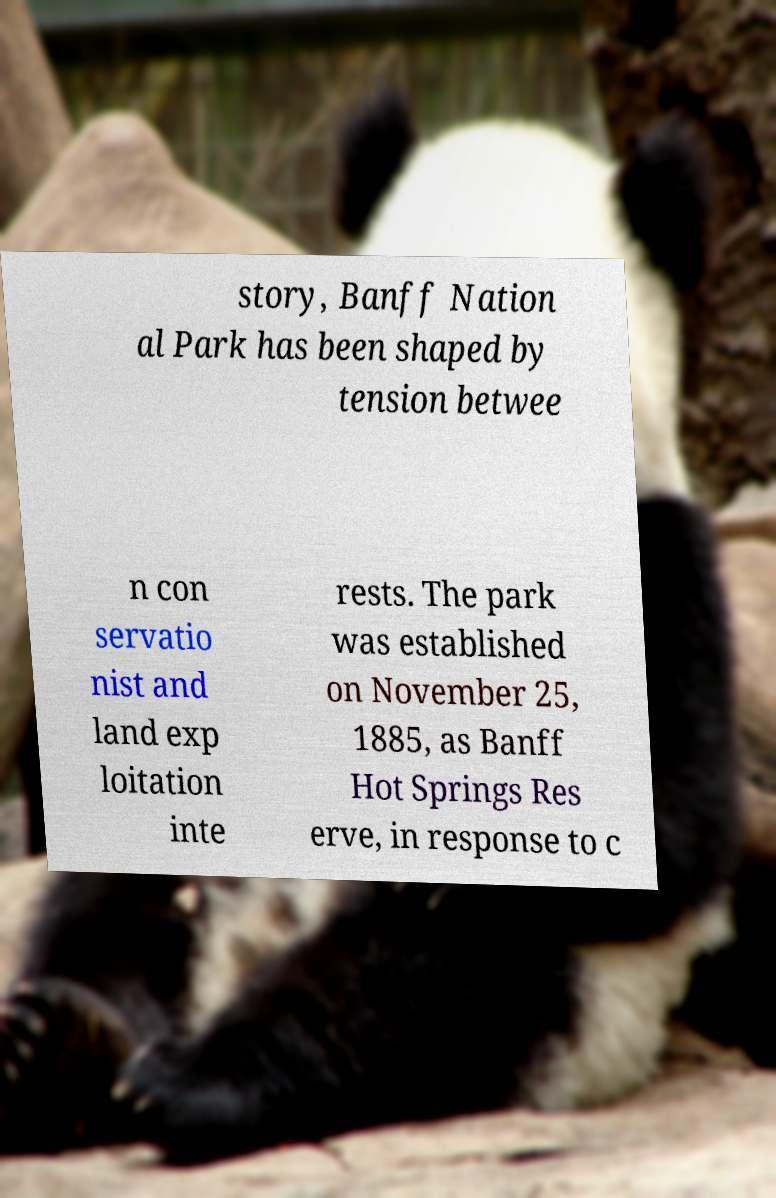What messages or text are displayed in this image? I need them in a readable, typed format. story, Banff Nation al Park has been shaped by tension betwee n con servatio nist and land exp loitation inte rests. The park was established on November 25, 1885, as Banff Hot Springs Res erve, in response to c 